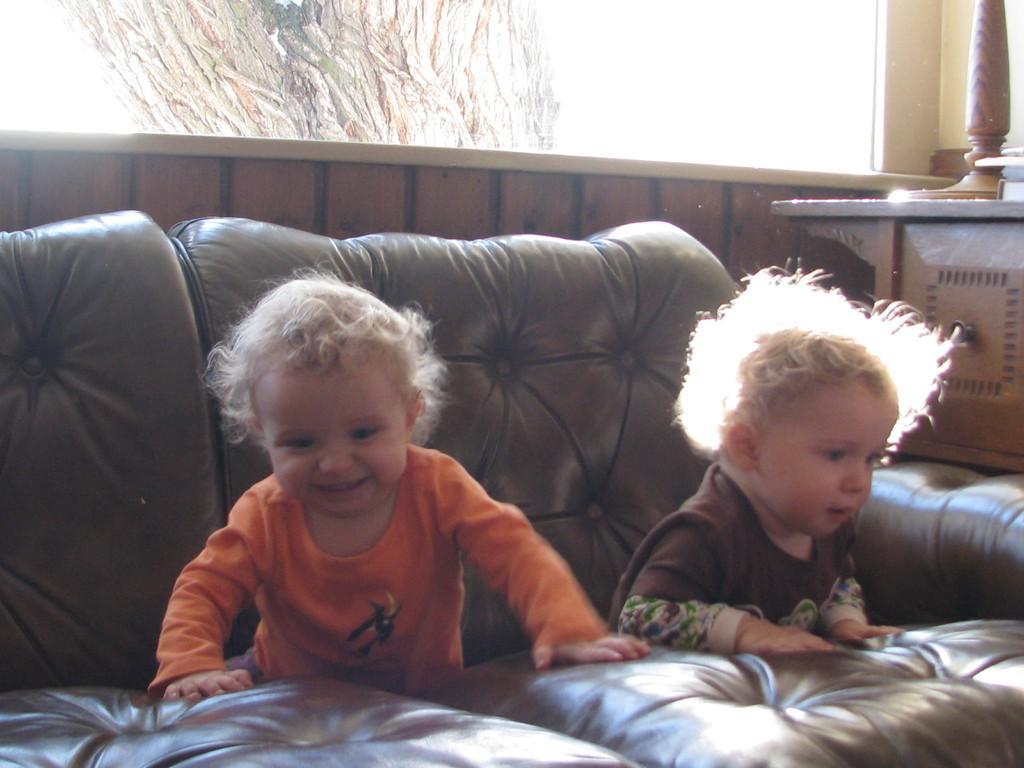How would you summarize this image in a sentence or two? There are two kids sitting on the couch. This couch is of brown in color. At the right corner of the image I can see a wooden desk with a some wooden object placed on the desk. At background I can see It looks like a window. 